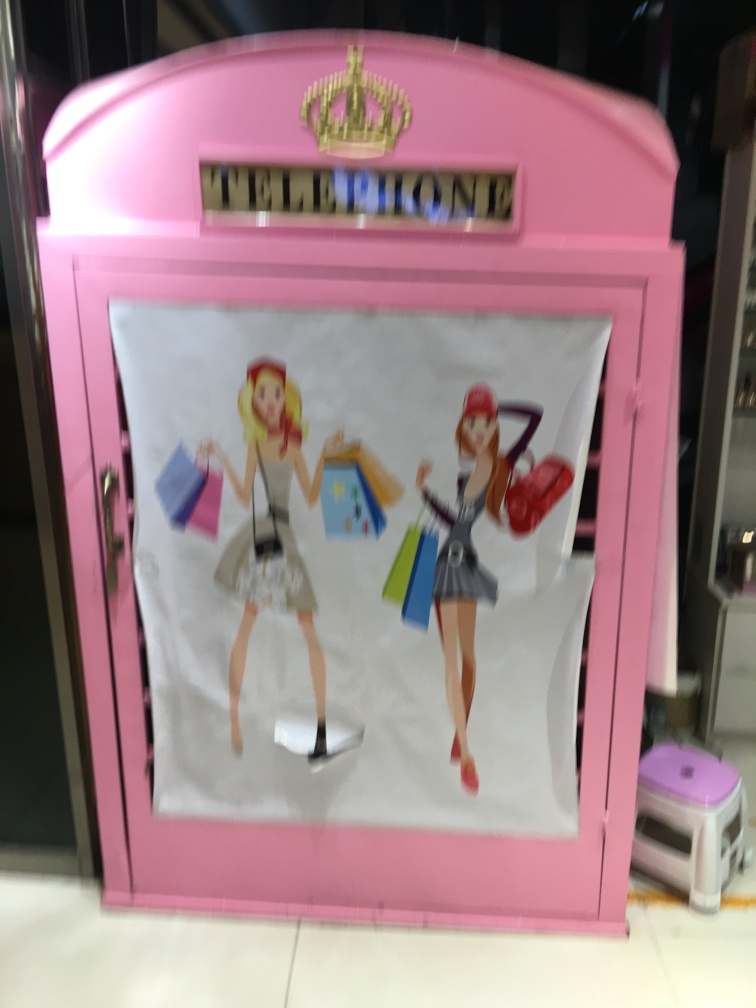What purpose do you think the telephone booth serves in its current location? Given its distinctive design and the presence of illustrated characters on the front, the telephone booth might be repurposed as a decorative piece or a photo opportunity spot in a shopping area or a themed park, rather than serving its traditional use for making phone calls. 